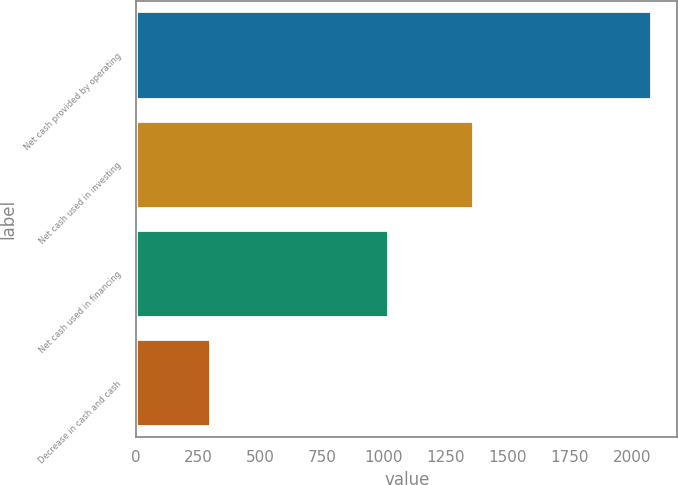<chart> <loc_0><loc_0><loc_500><loc_500><bar_chart><fcel>Net cash provided by operating<fcel>Net cash used in investing<fcel>Net cash used in financing<fcel>Decrease in cash and cash<nl><fcel>2079<fcel>1358<fcel>1017<fcel>296<nl></chart> 